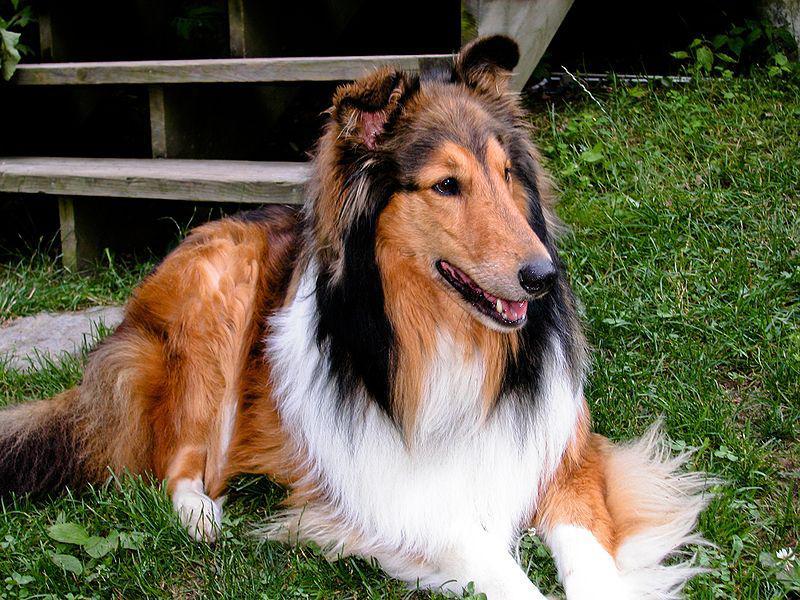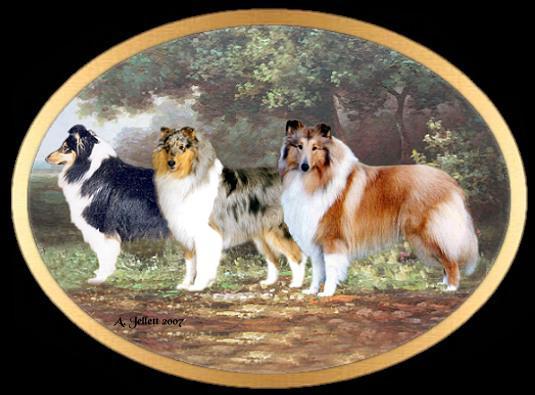The first image is the image on the left, the second image is the image on the right. For the images displayed, is the sentence "One image depicts exactly three collies standing in a row, each with a different fur coloring pattern." factually correct? Answer yes or no. Yes. The first image is the image on the left, the second image is the image on the right. For the images shown, is this caption "There are 4 dogs total" true? Answer yes or no. Yes. 